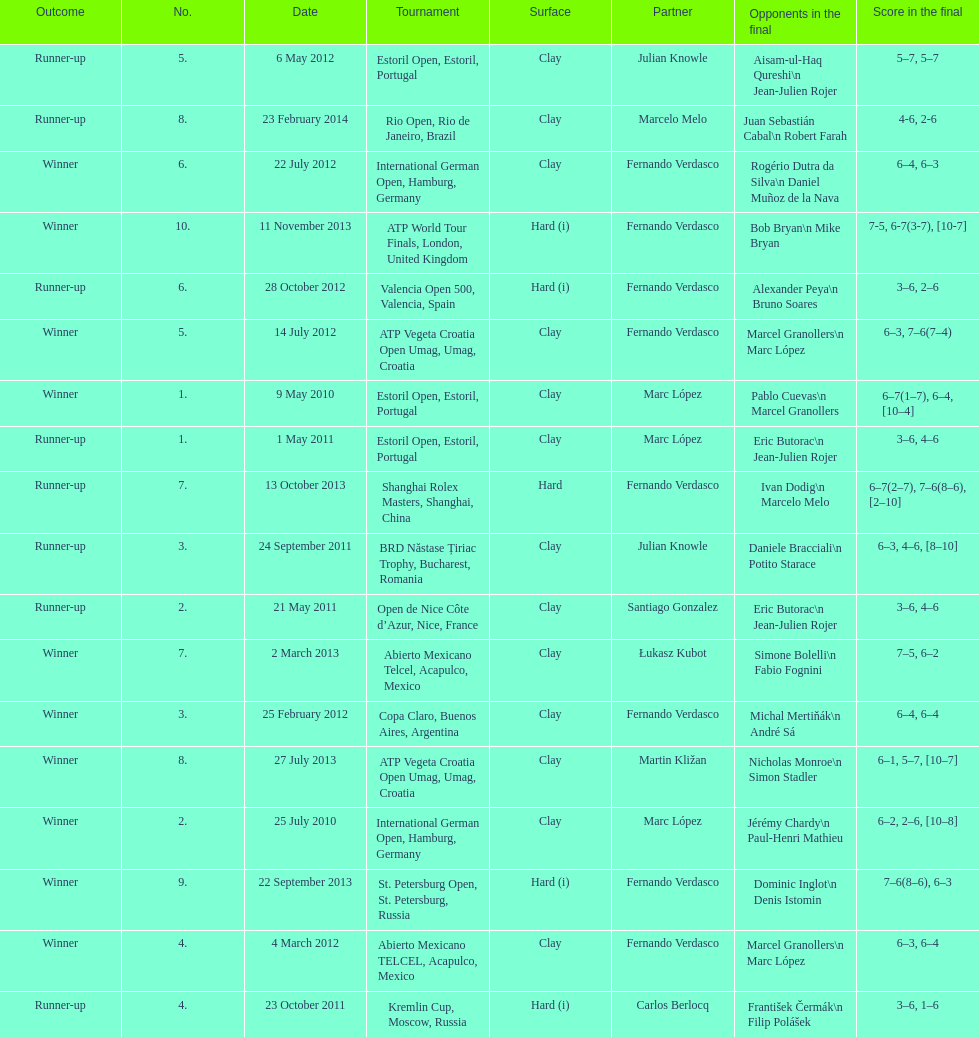Parse the table in full. {'header': ['Outcome', 'No.', 'Date', 'Tournament', 'Surface', 'Partner', 'Opponents in the final', 'Score in the final'], 'rows': [['Runner-up', '5.', '6 May 2012', 'Estoril Open, Estoril, Portugal', 'Clay', 'Julian Knowle', 'Aisam-ul-Haq Qureshi\\n Jean-Julien Rojer', '5–7, 5–7'], ['Runner-up', '8.', '23 February 2014', 'Rio Open, Rio de Janeiro, Brazil', 'Clay', 'Marcelo Melo', 'Juan Sebastián Cabal\\n Robert Farah', '4-6, 2-6'], ['Winner', '6.', '22 July 2012', 'International German Open, Hamburg, Germany', 'Clay', 'Fernando Verdasco', 'Rogério Dutra da Silva\\n Daniel Muñoz de la Nava', '6–4, 6–3'], ['Winner', '10.', '11 November 2013', 'ATP World Tour Finals, London, United Kingdom', 'Hard (i)', 'Fernando Verdasco', 'Bob Bryan\\n Mike Bryan', '7-5, 6-7(3-7), [10-7]'], ['Runner-up', '6.', '28 October 2012', 'Valencia Open 500, Valencia, Spain', 'Hard (i)', 'Fernando Verdasco', 'Alexander Peya\\n Bruno Soares', '3–6, 2–6'], ['Winner', '5.', '14 July 2012', 'ATP Vegeta Croatia Open Umag, Umag, Croatia', 'Clay', 'Fernando Verdasco', 'Marcel Granollers\\n Marc López', '6–3, 7–6(7–4)'], ['Winner', '1.', '9 May 2010', 'Estoril Open, Estoril, Portugal', 'Clay', 'Marc López', 'Pablo Cuevas\\n Marcel Granollers', '6–7(1–7), 6–4, [10–4]'], ['Runner-up', '1.', '1 May 2011', 'Estoril Open, Estoril, Portugal', 'Clay', 'Marc López', 'Eric Butorac\\n Jean-Julien Rojer', '3–6, 4–6'], ['Runner-up', '7.', '13 October 2013', 'Shanghai Rolex Masters, Shanghai, China', 'Hard', 'Fernando Verdasco', 'Ivan Dodig\\n Marcelo Melo', '6–7(2–7), 7–6(8–6), [2–10]'], ['Runner-up', '3.', '24 September 2011', 'BRD Năstase Țiriac Trophy, Bucharest, Romania', 'Clay', 'Julian Knowle', 'Daniele Bracciali\\n Potito Starace', '6–3, 4–6, [8–10]'], ['Runner-up', '2.', '21 May 2011', 'Open de Nice Côte d’Azur, Nice, France', 'Clay', 'Santiago Gonzalez', 'Eric Butorac\\n Jean-Julien Rojer', '3–6, 4–6'], ['Winner', '7.', '2 March 2013', 'Abierto Mexicano Telcel, Acapulco, Mexico', 'Clay', 'Łukasz Kubot', 'Simone Bolelli\\n Fabio Fognini', '7–5, 6–2'], ['Winner', '3.', '25 February 2012', 'Copa Claro, Buenos Aires, Argentina', 'Clay', 'Fernando Verdasco', 'Michal Mertiňák\\n André Sá', '6–4, 6–4'], ['Winner', '8.', '27 July 2013', 'ATP Vegeta Croatia Open Umag, Umag, Croatia', 'Clay', 'Martin Kližan', 'Nicholas Monroe\\n Simon Stadler', '6–1, 5–7, [10–7]'], ['Winner', '2.', '25 July 2010', 'International German Open, Hamburg, Germany', 'Clay', 'Marc López', 'Jérémy Chardy\\n Paul-Henri Mathieu', '6–2, 2–6, [10–8]'], ['Winner', '9.', '22 September 2013', 'St. Petersburg Open, St. Petersburg, Russia', 'Hard (i)', 'Fernando Verdasco', 'Dominic Inglot\\n Denis Istomin', '7–6(8–6), 6–3'], ['Winner', '4.', '4 March 2012', 'Abierto Mexicano TELCEL, Acapulco, Mexico', 'Clay', 'Fernando Verdasco', 'Marcel Granollers\\n Marc López', '6–3, 6–4'], ['Runner-up', '4.', '23 October 2011', 'Kremlin Cup, Moscow, Russia', 'Hard (i)', 'Carlos Berlocq', 'František Čermák\\n Filip Polášek', '3–6, 1–6']]} Who won both the st.petersburg open and the atp world tour finals? Fernando Verdasco. 